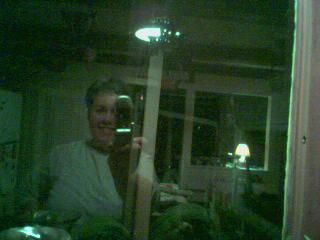What is this person trying to take a picture of?
Short answer required. Self. Is the person inside or outside?
Give a very brief answer. Inside. Is this the best way to take a selfie?
Keep it brief. No. 